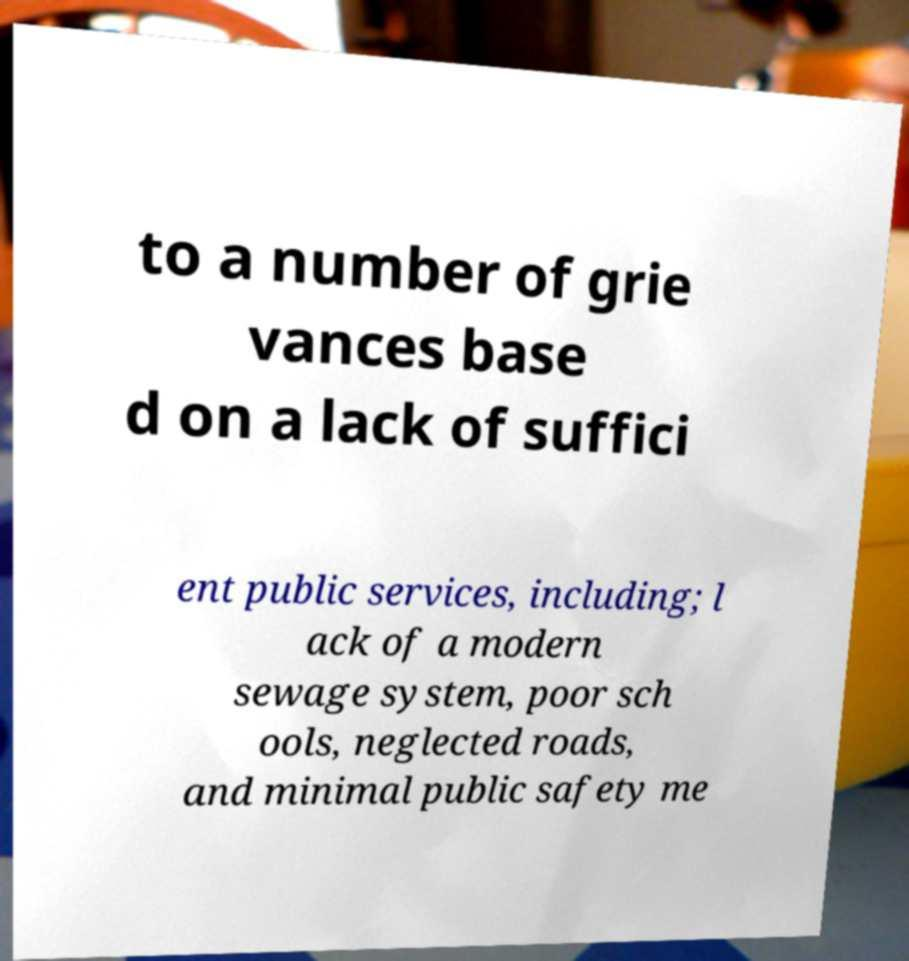What messages or text are displayed in this image? I need them in a readable, typed format. to a number of grie vances base d on a lack of suffici ent public services, including; l ack of a modern sewage system, poor sch ools, neglected roads, and minimal public safety me 